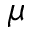Convert formula to latex. <formula><loc_0><loc_0><loc_500><loc_500>\mu</formula> 